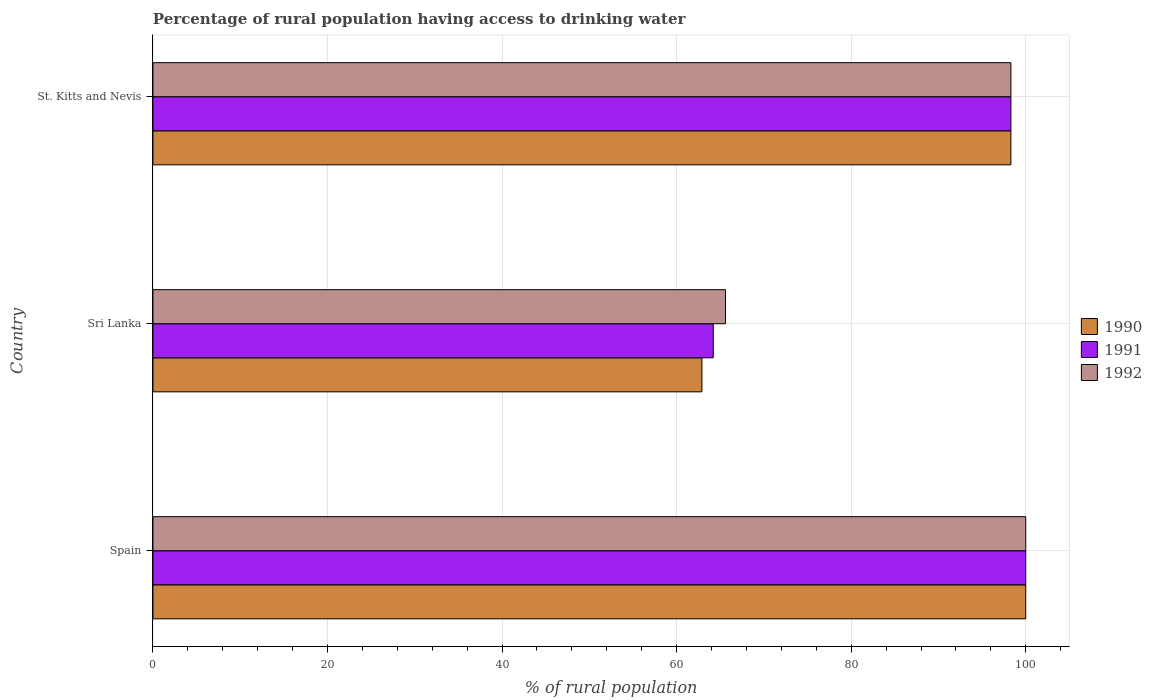How many different coloured bars are there?
Make the answer very short. 3. Are the number of bars per tick equal to the number of legend labels?
Provide a short and direct response. Yes. How many bars are there on the 3rd tick from the bottom?
Keep it short and to the point. 3. What is the label of the 2nd group of bars from the top?
Your answer should be very brief. Sri Lanka. What is the percentage of rural population having access to drinking water in 1992 in Sri Lanka?
Your answer should be very brief. 65.6. Across all countries, what is the maximum percentage of rural population having access to drinking water in 1990?
Offer a very short reply. 100. Across all countries, what is the minimum percentage of rural population having access to drinking water in 1991?
Your answer should be very brief. 64.2. In which country was the percentage of rural population having access to drinking water in 1992 maximum?
Your answer should be very brief. Spain. In which country was the percentage of rural population having access to drinking water in 1990 minimum?
Make the answer very short. Sri Lanka. What is the total percentage of rural population having access to drinking water in 1990 in the graph?
Your answer should be very brief. 261.2. What is the difference between the percentage of rural population having access to drinking water in 1991 in Spain and that in Sri Lanka?
Your answer should be compact. 35.8. What is the difference between the percentage of rural population having access to drinking water in 1990 in Spain and the percentage of rural population having access to drinking water in 1991 in St. Kitts and Nevis?
Your answer should be compact. 1.7. What is the average percentage of rural population having access to drinking water in 1990 per country?
Provide a short and direct response. 87.07. What is the difference between the percentage of rural population having access to drinking water in 1992 and percentage of rural population having access to drinking water in 1991 in St. Kitts and Nevis?
Your answer should be compact. 0. In how many countries, is the percentage of rural population having access to drinking water in 1990 greater than 56 %?
Provide a short and direct response. 3. What is the ratio of the percentage of rural population having access to drinking water in 1992 in Spain to that in Sri Lanka?
Give a very brief answer. 1.52. Is the percentage of rural population having access to drinking water in 1991 in Sri Lanka less than that in St. Kitts and Nevis?
Your answer should be compact. Yes. Is the difference between the percentage of rural population having access to drinking water in 1992 in Sri Lanka and St. Kitts and Nevis greater than the difference between the percentage of rural population having access to drinking water in 1991 in Sri Lanka and St. Kitts and Nevis?
Your response must be concise. Yes. What is the difference between the highest and the second highest percentage of rural population having access to drinking water in 1992?
Ensure brevity in your answer.  1.7. What is the difference between the highest and the lowest percentage of rural population having access to drinking water in 1990?
Offer a very short reply. 37.1. In how many countries, is the percentage of rural population having access to drinking water in 1991 greater than the average percentage of rural population having access to drinking water in 1991 taken over all countries?
Offer a terse response. 2. Is the sum of the percentage of rural population having access to drinking water in 1990 in Spain and Sri Lanka greater than the maximum percentage of rural population having access to drinking water in 1992 across all countries?
Ensure brevity in your answer.  Yes. Is it the case that in every country, the sum of the percentage of rural population having access to drinking water in 1992 and percentage of rural population having access to drinking water in 1990 is greater than the percentage of rural population having access to drinking water in 1991?
Keep it short and to the point. Yes. Are all the bars in the graph horizontal?
Your response must be concise. Yes. What is the difference between two consecutive major ticks on the X-axis?
Provide a short and direct response. 20. Are the values on the major ticks of X-axis written in scientific E-notation?
Give a very brief answer. No. Does the graph contain any zero values?
Offer a terse response. No. Does the graph contain grids?
Make the answer very short. Yes. How many legend labels are there?
Give a very brief answer. 3. How are the legend labels stacked?
Ensure brevity in your answer.  Vertical. What is the title of the graph?
Your response must be concise. Percentage of rural population having access to drinking water. What is the label or title of the X-axis?
Provide a succinct answer. % of rural population. What is the label or title of the Y-axis?
Offer a very short reply. Country. What is the % of rural population in 1991 in Spain?
Give a very brief answer. 100. What is the % of rural population of 1990 in Sri Lanka?
Provide a succinct answer. 62.9. What is the % of rural population of 1991 in Sri Lanka?
Your answer should be very brief. 64.2. What is the % of rural population in 1992 in Sri Lanka?
Offer a terse response. 65.6. What is the % of rural population of 1990 in St. Kitts and Nevis?
Your answer should be very brief. 98.3. What is the % of rural population of 1991 in St. Kitts and Nevis?
Your response must be concise. 98.3. What is the % of rural population of 1992 in St. Kitts and Nevis?
Give a very brief answer. 98.3. Across all countries, what is the maximum % of rural population of 1991?
Offer a terse response. 100. Across all countries, what is the minimum % of rural population in 1990?
Offer a very short reply. 62.9. Across all countries, what is the minimum % of rural population in 1991?
Provide a short and direct response. 64.2. Across all countries, what is the minimum % of rural population of 1992?
Your answer should be very brief. 65.6. What is the total % of rural population of 1990 in the graph?
Give a very brief answer. 261.2. What is the total % of rural population of 1991 in the graph?
Your answer should be very brief. 262.5. What is the total % of rural population of 1992 in the graph?
Your answer should be compact. 263.9. What is the difference between the % of rural population in 1990 in Spain and that in Sri Lanka?
Provide a succinct answer. 37.1. What is the difference between the % of rural population of 1991 in Spain and that in Sri Lanka?
Offer a very short reply. 35.8. What is the difference between the % of rural population of 1992 in Spain and that in Sri Lanka?
Your answer should be compact. 34.4. What is the difference between the % of rural population in 1992 in Spain and that in St. Kitts and Nevis?
Give a very brief answer. 1.7. What is the difference between the % of rural population of 1990 in Sri Lanka and that in St. Kitts and Nevis?
Give a very brief answer. -35.4. What is the difference between the % of rural population of 1991 in Sri Lanka and that in St. Kitts and Nevis?
Your answer should be very brief. -34.1. What is the difference between the % of rural population in 1992 in Sri Lanka and that in St. Kitts and Nevis?
Provide a short and direct response. -32.7. What is the difference between the % of rural population in 1990 in Spain and the % of rural population in 1991 in Sri Lanka?
Offer a terse response. 35.8. What is the difference between the % of rural population in 1990 in Spain and the % of rural population in 1992 in Sri Lanka?
Ensure brevity in your answer.  34.4. What is the difference between the % of rural population in 1991 in Spain and the % of rural population in 1992 in Sri Lanka?
Make the answer very short. 34.4. What is the difference between the % of rural population in 1990 in Spain and the % of rural population in 1991 in St. Kitts and Nevis?
Give a very brief answer. 1.7. What is the difference between the % of rural population of 1990 in Spain and the % of rural population of 1992 in St. Kitts and Nevis?
Keep it short and to the point. 1.7. What is the difference between the % of rural population in 1991 in Spain and the % of rural population in 1992 in St. Kitts and Nevis?
Offer a terse response. 1.7. What is the difference between the % of rural population in 1990 in Sri Lanka and the % of rural population in 1991 in St. Kitts and Nevis?
Your answer should be very brief. -35.4. What is the difference between the % of rural population of 1990 in Sri Lanka and the % of rural population of 1992 in St. Kitts and Nevis?
Make the answer very short. -35.4. What is the difference between the % of rural population in 1991 in Sri Lanka and the % of rural population in 1992 in St. Kitts and Nevis?
Offer a terse response. -34.1. What is the average % of rural population of 1990 per country?
Provide a succinct answer. 87.07. What is the average % of rural population in 1991 per country?
Your response must be concise. 87.5. What is the average % of rural population of 1992 per country?
Offer a very short reply. 87.97. What is the difference between the % of rural population in 1990 and % of rural population in 1991 in Spain?
Provide a succinct answer. 0. What is the difference between the % of rural population in 1990 and % of rural population in 1992 in Spain?
Provide a succinct answer. 0. What is the difference between the % of rural population of 1990 and % of rural population of 1991 in Sri Lanka?
Provide a short and direct response. -1.3. What is the difference between the % of rural population in 1990 and % of rural population in 1991 in St. Kitts and Nevis?
Your answer should be very brief. 0. What is the difference between the % of rural population in 1990 and % of rural population in 1992 in St. Kitts and Nevis?
Make the answer very short. 0. What is the difference between the % of rural population in 1991 and % of rural population in 1992 in St. Kitts and Nevis?
Offer a very short reply. 0. What is the ratio of the % of rural population of 1990 in Spain to that in Sri Lanka?
Provide a short and direct response. 1.59. What is the ratio of the % of rural population in 1991 in Spain to that in Sri Lanka?
Offer a terse response. 1.56. What is the ratio of the % of rural population in 1992 in Spain to that in Sri Lanka?
Provide a succinct answer. 1.52. What is the ratio of the % of rural population in 1990 in Spain to that in St. Kitts and Nevis?
Offer a terse response. 1.02. What is the ratio of the % of rural population in 1991 in Spain to that in St. Kitts and Nevis?
Your answer should be very brief. 1.02. What is the ratio of the % of rural population in 1992 in Spain to that in St. Kitts and Nevis?
Your response must be concise. 1.02. What is the ratio of the % of rural population in 1990 in Sri Lanka to that in St. Kitts and Nevis?
Offer a terse response. 0.64. What is the ratio of the % of rural population of 1991 in Sri Lanka to that in St. Kitts and Nevis?
Provide a short and direct response. 0.65. What is the ratio of the % of rural population of 1992 in Sri Lanka to that in St. Kitts and Nevis?
Keep it short and to the point. 0.67. What is the difference between the highest and the second highest % of rural population of 1990?
Keep it short and to the point. 1.7. What is the difference between the highest and the lowest % of rural population in 1990?
Your answer should be compact. 37.1. What is the difference between the highest and the lowest % of rural population of 1991?
Provide a succinct answer. 35.8. What is the difference between the highest and the lowest % of rural population of 1992?
Your answer should be compact. 34.4. 